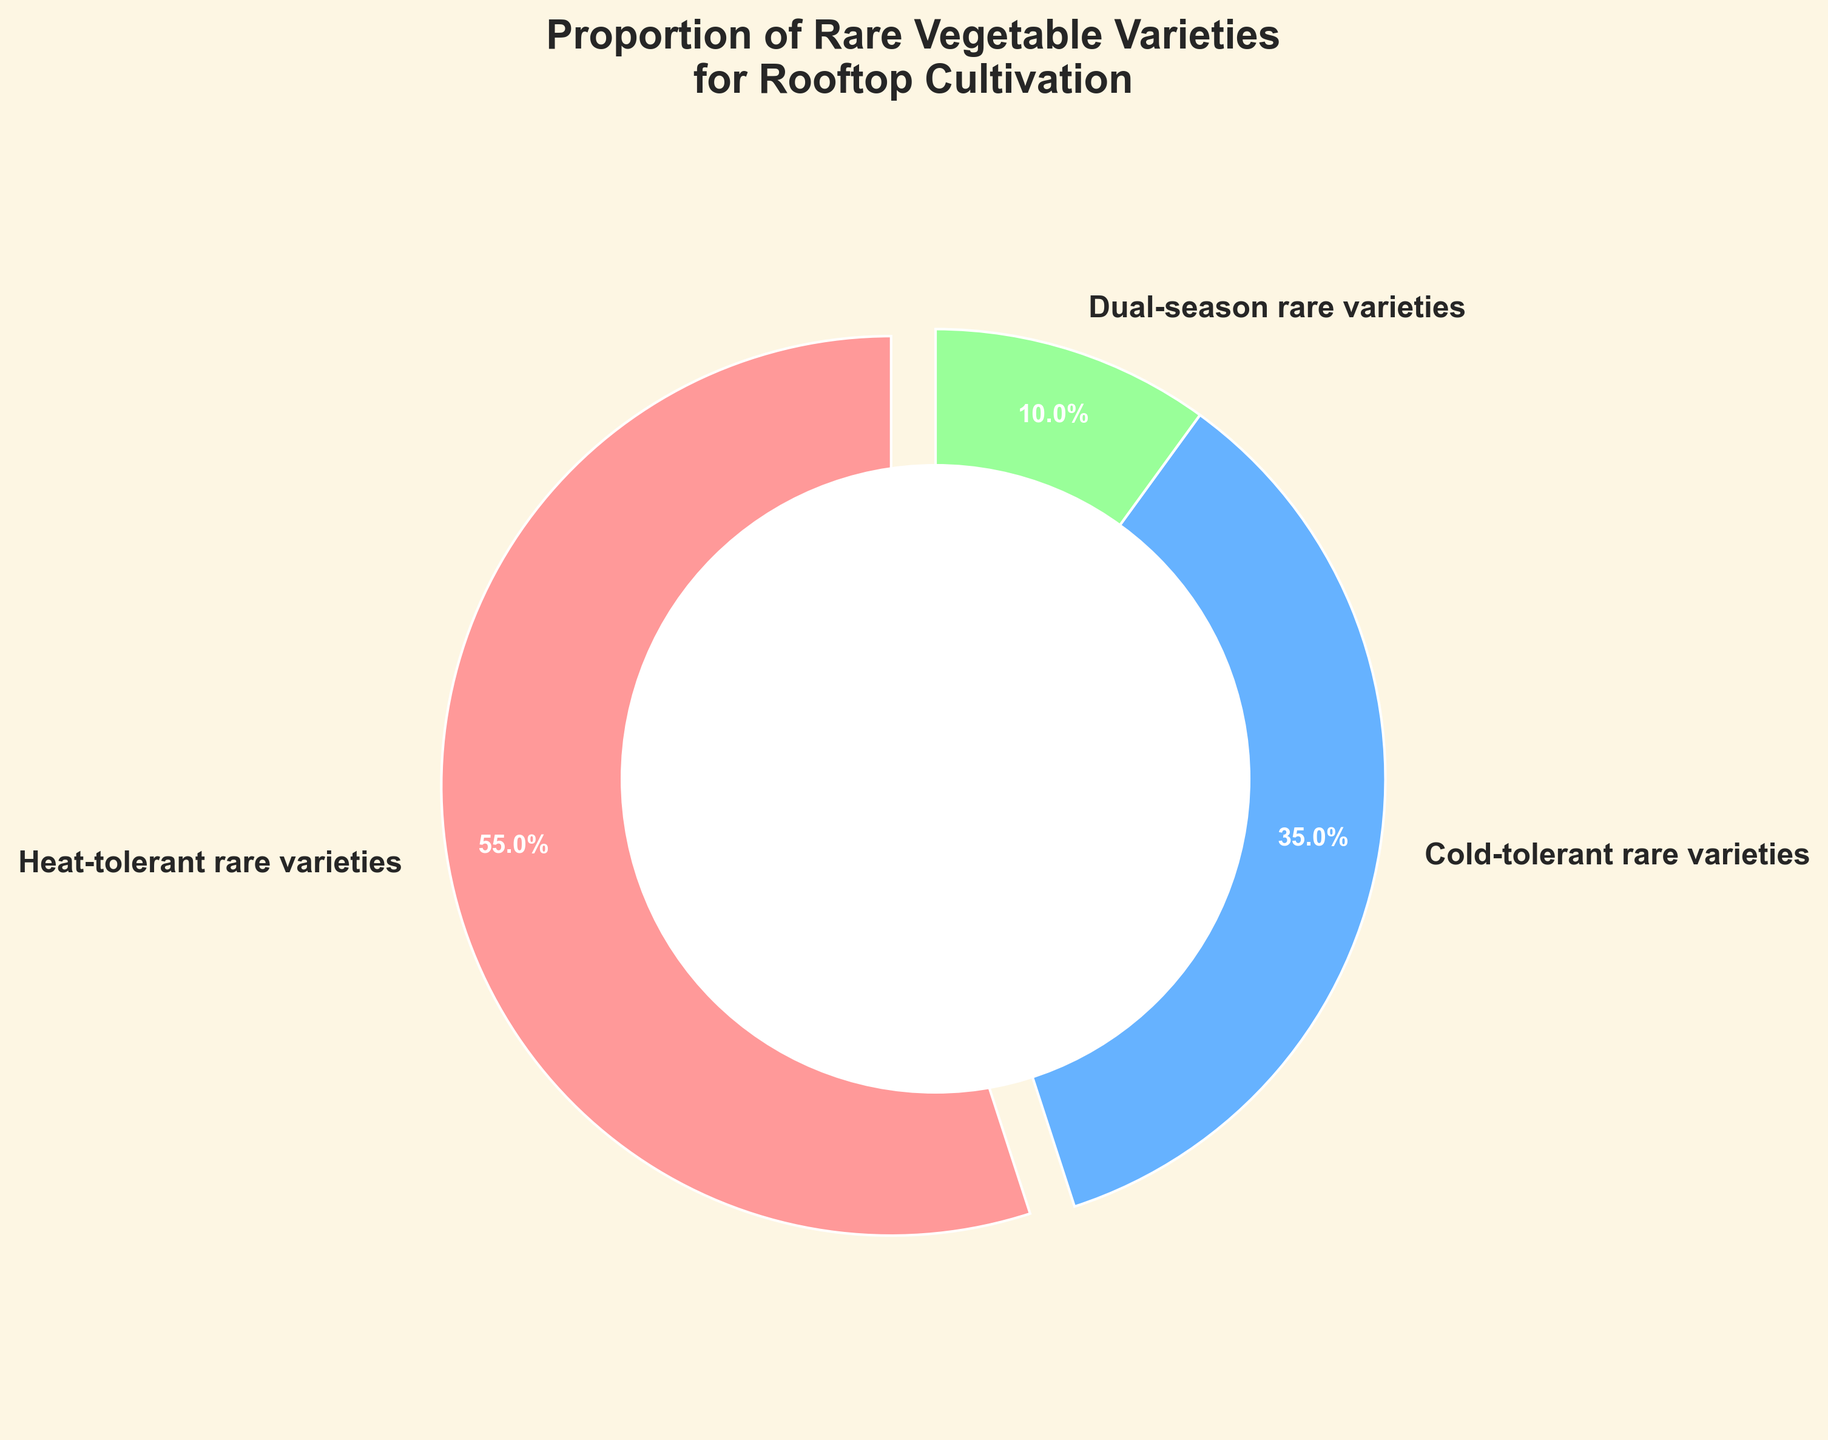What percentage of the rare vegetable varieties are heat-tolerant? The pie chart shows three categories: heat-tolerant (55%), cold-tolerant (35%), and dual-season (10%). The heat-tolerant category is labeled with 55%.
Answer: 55% What is the combined percentage of rare vegetable varieties that can tolerate either heat or cold? Combine the percentages of heat-tolerant (55%) and cold-tolerant (35%). 55% + 35% = 90%
Answer: 90% Which category has the smallest proportion? The pie chart divides the categories into heat-tolerant (55%), cold-tolerant (35%), and dual-season (10%). The smallest percentage is 10%.
Answer: Dual-season rare varieties Which category has a larger proportion: heat-tolerant or cold-tolerant? The pie chart shows heat-tolerant at 55% and cold-tolerant at 35%. 55% is greater than 35%.
Answer: Heat-tolerant rare varieties What is the difference in percentage between heat-tolerant and dual-season rare vegetable varieties? Subtract the percentage of dual-season (10%) from heat-tolerant (55%). So, 55% - 10% = 45%
Answer: 45% If you exclude dual-season varieties, what percent of the remaining varieties are cold-tolerant? The remaining varieties are heat-tolerant (55%) and cold-tolerant (35%), which totals 90%. The percentage of cold-tolerant out of this total is (35/90) * 100 = 38.9%
Answer: 38.9% Which category is represented by the red color in the pie chart? The red section of the pie chart corresponds to the heat-tolerant category.
Answer: Heat-tolerant rare varieties How many times larger is the proportion of heat-tolerant varieties compared to dual-season varieties? The heat-tolerant varieties are at 55% while dual-season varieties are at 10%. Divide 55 by 10. 55 / 10 = 5.5. So, the heat-tolerant proportion is 5.5 times larger than dual-season.
Answer: 5.5 times What's the ratio of heat-tolerant to cold-tolerant varieties? The pie chart shows heat-tolerant at 55% and cold-tolerant at 35%. The ratio is 55:35. Simplify it by dividing both by 5, so the ratio is 11:7.
Answer: 11:7 